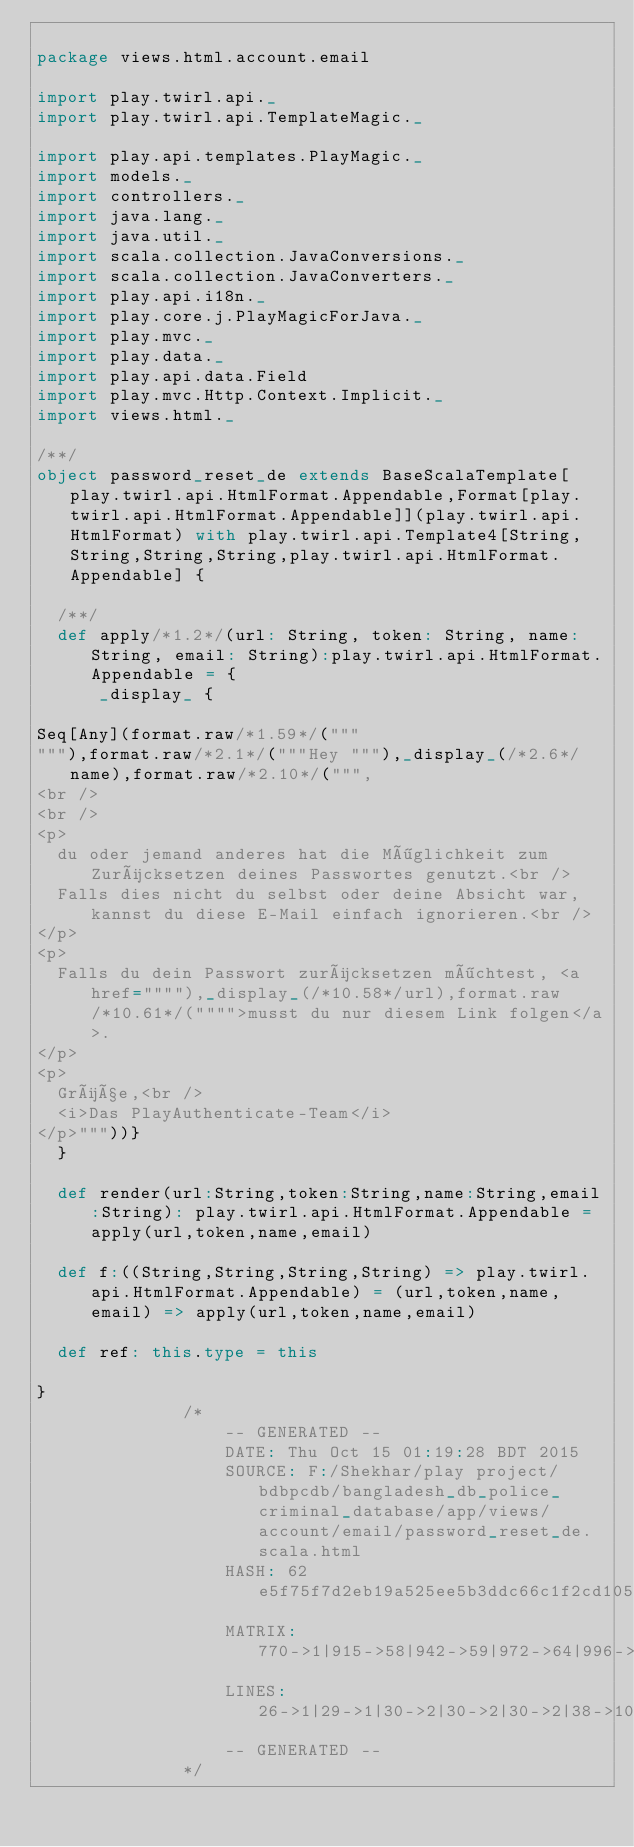Convert code to text. <code><loc_0><loc_0><loc_500><loc_500><_Scala_>
package views.html.account.email

import play.twirl.api._
import play.twirl.api.TemplateMagic._

import play.api.templates.PlayMagic._
import models._
import controllers._
import java.lang._
import java.util._
import scala.collection.JavaConversions._
import scala.collection.JavaConverters._
import play.api.i18n._
import play.core.j.PlayMagicForJava._
import play.mvc._
import play.data._
import play.api.data.Field
import play.mvc.Http.Context.Implicit._
import views.html._

/**/
object password_reset_de extends BaseScalaTemplate[play.twirl.api.HtmlFormat.Appendable,Format[play.twirl.api.HtmlFormat.Appendable]](play.twirl.api.HtmlFormat) with play.twirl.api.Template4[String,String,String,String,play.twirl.api.HtmlFormat.Appendable] {

  /**/
  def apply/*1.2*/(url: String, token: String, name: String, email: String):play.twirl.api.HtmlFormat.Appendable = {
      _display_ {

Seq[Any](format.raw/*1.59*/("""
"""),format.raw/*2.1*/("""Hey """),_display_(/*2.6*/name),format.raw/*2.10*/(""",
<br />
<br />
<p>
	du oder jemand anderes hat die Möglichkeit zum Zurücksetzen deines Passwortes genutzt.<br />
	Falls dies nicht du selbst oder deine Absicht war, kannst du diese E-Mail einfach ignorieren.<br />
</p>
<p>
	Falls du dein Passwort zurücksetzen möchtest, <a href=""""),_display_(/*10.58*/url),format.raw/*10.61*/("""">musst du nur diesem Link folgen</a>.
</p>
<p>
	Grüße,<br /> 
	<i>Das PlayAuthenticate-Team</i>
</p>"""))}
  }

  def render(url:String,token:String,name:String,email:String): play.twirl.api.HtmlFormat.Appendable = apply(url,token,name,email)

  def f:((String,String,String,String) => play.twirl.api.HtmlFormat.Appendable) = (url,token,name,email) => apply(url,token,name,email)

  def ref: this.type = this

}
              /*
                  -- GENERATED --
                  DATE: Thu Oct 15 01:19:28 BDT 2015
                  SOURCE: F:/Shekhar/play project/bdbpcdb/bangladesh_db_police_criminal_database/app/views/account/email/password_reset_de.scala.html
                  HASH: 62e5f75f7d2eb19a525ee5b3ddc66c1f2cd10504
                  MATRIX: 770->1|915->58|942->59|972->64|996->68|1304->349|1328->352
                  LINES: 26->1|29->1|30->2|30->2|30->2|38->10|38->10
                  -- GENERATED --
              */
          </code> 